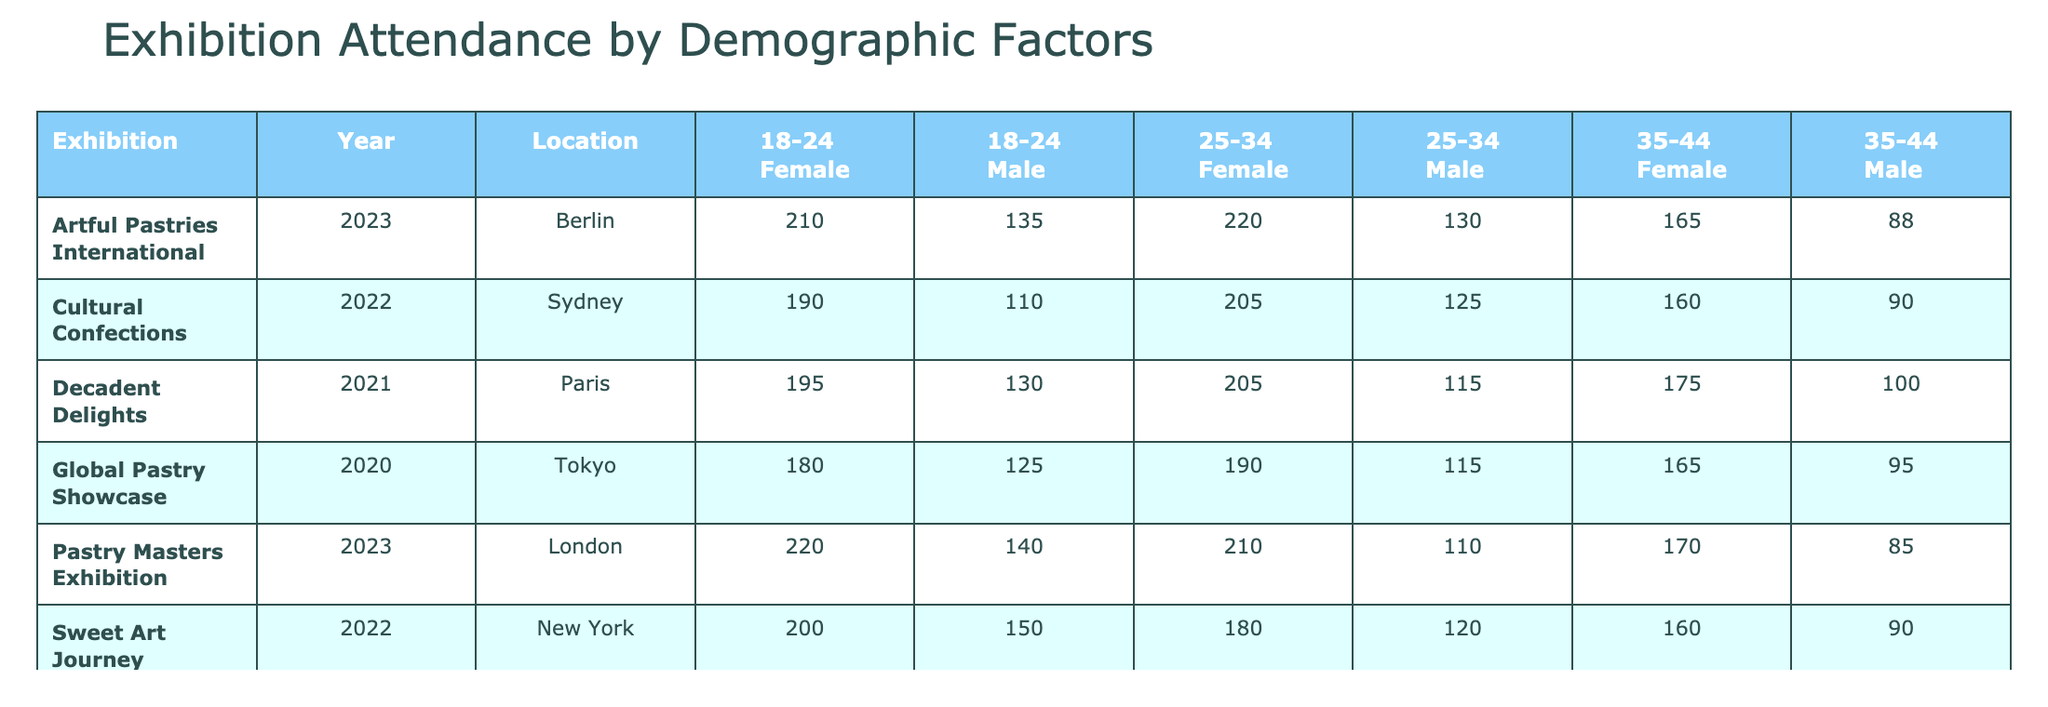What was the attendance for female visitors aged 25-34 at the "Sweet Art Journey" exhibition in 2022? The table shows the attendance data for each demographic group. Looking under "Sweet Art Journey" for the year 2022 and the female category in the 25-34 age group, the attendance number is 180.
Answer: 180 Which exhibition had the highest male attendance in the 35-44 age group? The table allows us to examine the male attendance for the age group 35-44 across all exhibitions. The highest value for male attendance in this age group is 100 at the "Decadent Delights" exhibition in 2021.
Answer: 100 What is the total attendance for female visitors in the 18-24 age group across all exhibitions? To find this total, we add the values for female attendees aged 18-24 across all exhibitions: 200 (Sweet Art Journey) + 220 (Pastry Masters Exhibition) + 195 (Decadent Delights) + 180 (Global Pastry Showcase) + 190 (Cultural Confections) + 210 (Artful Pastries International) = 1195.
Answer: 1195 Did the "Cultural Confections" exhibition in 2022 have a higher attendance for males or females in the 25-34 age group? Checking the table, the attendance is 125 for males and 205 for females in the 25-34 age group. Since 205 > 125, the female attendance is higher.
Answer: Yes What is the average attendance for female visitors across all exhibitions? To find the average for female visitors, we first sum all female attendance numbers: 200 + 180 + 160 + 220 + 210 + 195 + 205 + 180 + 205 + 210 + 165 = 2100. There are 11 values, so the average is 2100 / 11 ≈ 190.91.
Answer: 190.91 What was the difference in total attendance between males and females for "Global Pastry Showcase" in 2020? For "Global Pastry Showcase" in 2020, male attendance was 125 + 115 + 95 = 335, and female attendance was 180 + 190 + 165 = 535. The difference is 535 - 335 = 200, meaning females had higher attendance.
Answer: 200 Which age group had the highest overall attendance at the "Pastry Masters Exhibition" in 2023? The attendance numbers from the table for "Pastry Masters Exhibition" in 2023 are: 140 (18-24, Male) + 220 (18-24, Female) + 110 (25-34, Male) + 210 (25-34, Female) + 85 (35-44, Male) + 170 (35-44, Female) = 1035. In each age group, the numbers are: 18-24 (360), 25-34 (320), and 35-44 (255). The highest group is 18-24 with 360.
Answer: 18-24 Was the total attendance for the "Artful Pastries International" exhibition higher than the "Decadent Delights" exhibition? For "Artful Pastries International" (2023), the total attendance is: 135 + 210 + 130 + 220 + 88 + 165 = 1,048. For "Decadent Delights" (2021), it is: 130 + 195 + 115 + 205 + 100 + 175 = 1,020. Since 1,048 > 1,020, the attendance was higher for "Artful Pastries International."
Answer: Yes 